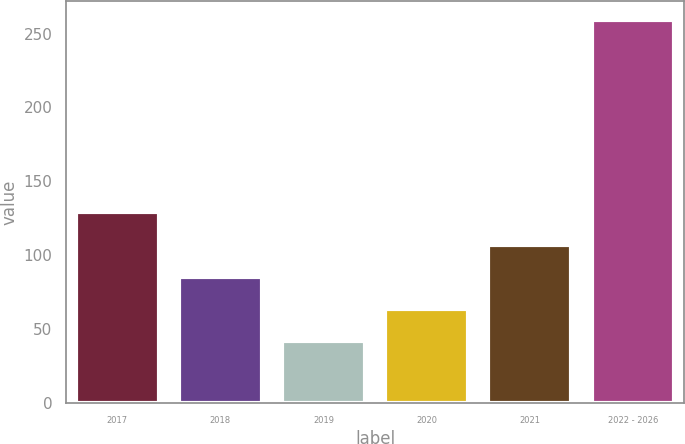Convert chart. <chart><loc_0><loc_0><loc_500><loc_500><bar_chart><fcel>2017<fcel>2018<fcel>2019<fcel>2020<fcel>2021<fcel>2022 - 2026<nl><fcel>128.8<fcel>85.4<fcel>42<fcel>63.7<fcel>107.1<fcel>259<nl></chart> 